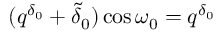Convert formula to latex. <formula><loc_0><loc_0><loc_500><loc_500>( q ^ { \delta _ { 0 } } + \tilde { \delta } _ { 0 } ) \cos \omega _ { 0 } = q ^ { \delta _ { 0 } }</formula> 